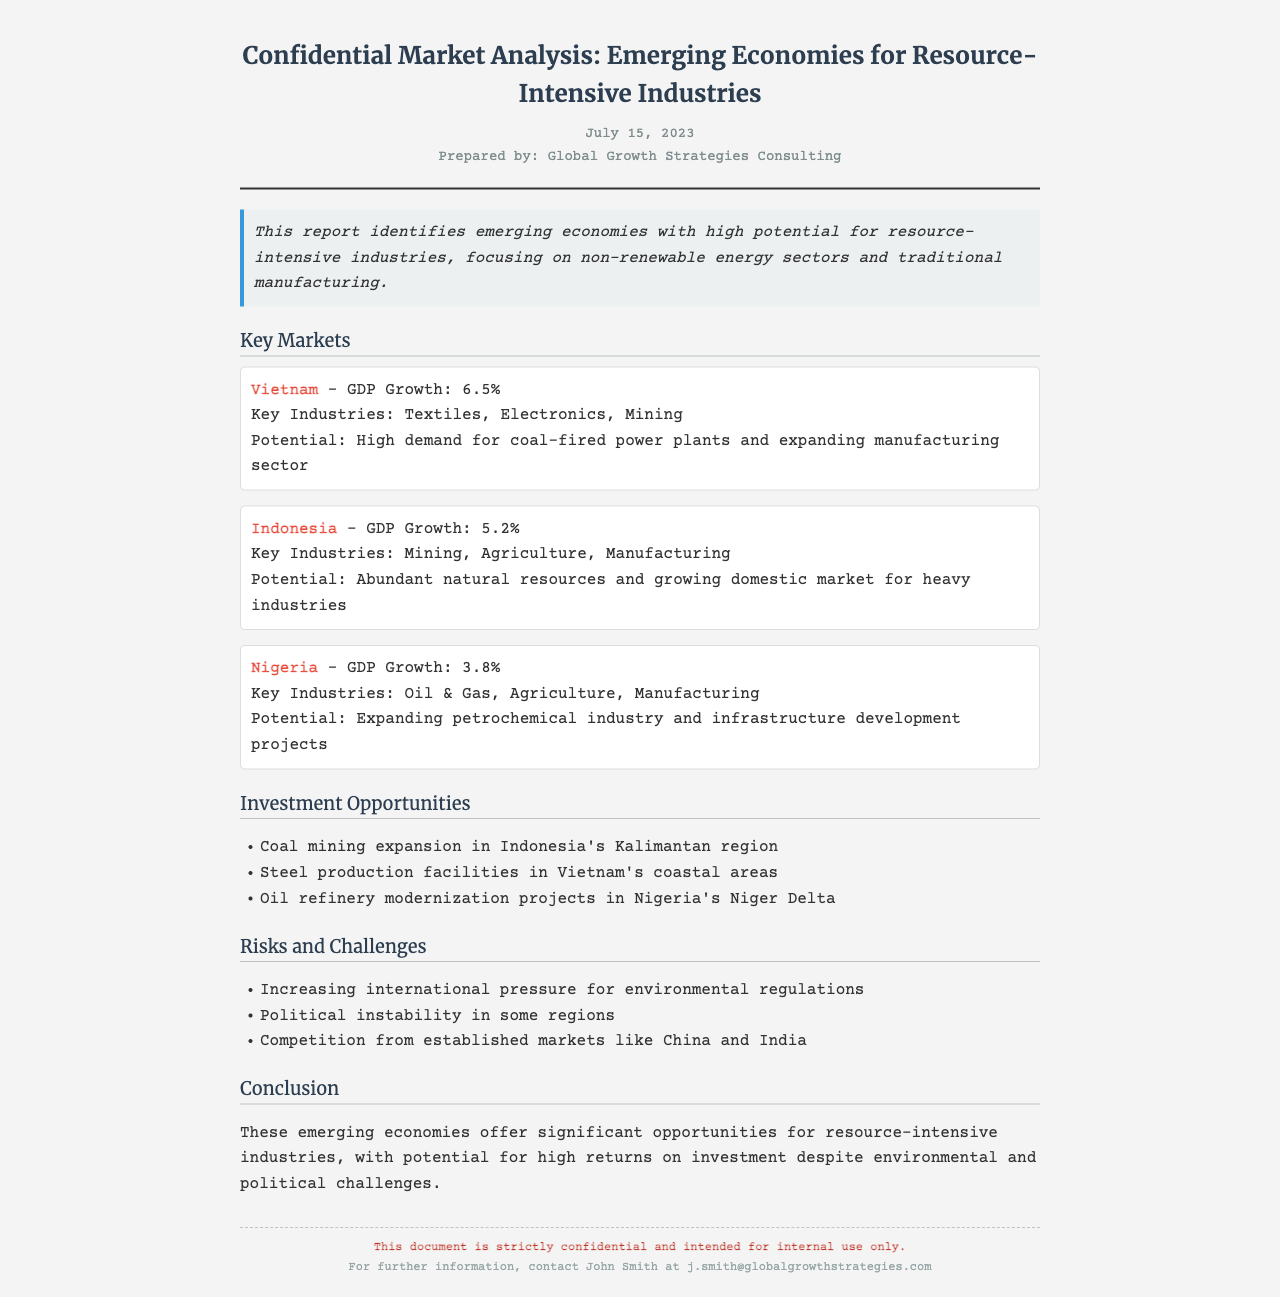what is the date of the report? The date is stated at the top of the document, indicating when the report was prepared.
Answer: July 15, 2023 who prepared the document? The prepared by section reveals the organization responsible for the report.
Answer: Global Growth Strategies Consulting which country has the highest GDP growth rate mentioned? The key market section lists the GDP growth rates for each country, allowing for comparison.
Answer: Vietnam what are the key industries in Nigeria? The information provided under the key market for Nigeria specifies its key industries.
Answer: Oil & Gas, Agriculture, Manufacturing list one investment opportunity mentioned in the report. The investment opportunities section outlines specific projects available for investment.
Answer: Coal mining expansion in Indonesia's Kalimantan region what is one risk mentioned in the report? The risks and challenges section enumerates potential issues that could affect investments.
Answer: Increasing international pressure for environmental regulations what is the conclusion about emerging economies? The conclusion summarizes the overall assessment of the opportunities within emerging economies.
Answer: Significant opportunities for resource-intensive industries which country is associated with steel production facilities? The investment opportunities section specifies the locations of various investment projects, including steel production.
Answer: Vietnam 